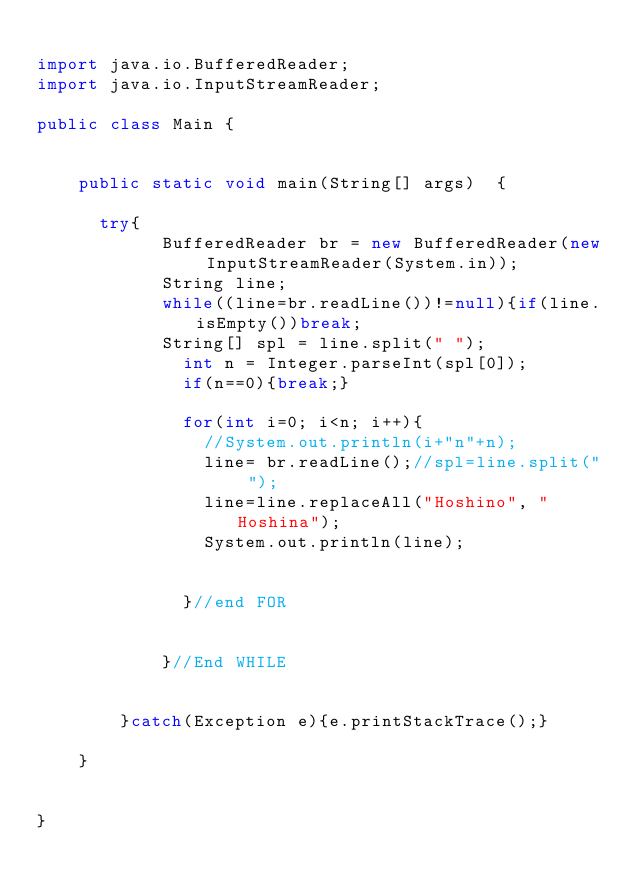Convert code to text. <code><loc_0><loc_0><loc_500><loc_500><_Java_>
import java.io.BufferedReader;
import java.io.InputStreamReader;

public class Main {


    public static void main(String[] args)  {

    	try{
            BufferedReader br = new BufferedReader(new InputStreamReader(System.in));
            String line;
            while((line=br.readLine())!=null){if(line.isEmpty())break;
	        	String[] spl = line.split(" ");
	            int n = Integer.parseInt(spl[0]);
	            if(n==0){break;}

	            for(int i=0; i<n; i++){
	            	//System.out.println(i+"n"+n);
	            	line= br.readLine();//spl=line.split(" ");
	            	line=line.replaceAll("Hoshino", "Hoshina");
	            	System.out.println(line);


	            }//end FOR


            }//End WHILE


        }catch(Exception e){e.printStackTrace();}

    }


}</code> 